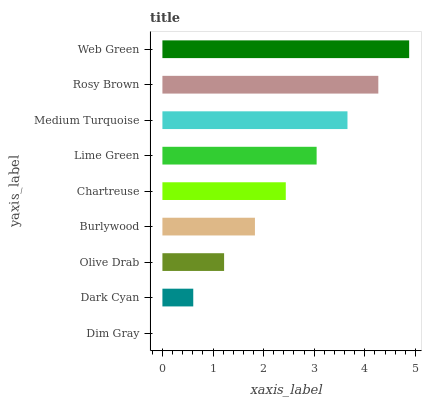Is Dim Gray the minimum?
Answer yes or no. Yes. Is Web Green the maximum?
Answer yes or no. Yes. Is Dark Cyan the minimum?
Answer yes or no. No. Is Dark Cyan the maximum?
Answer yes or no. No. Is Dark Cyan greater than Dim Gray?
Answer yes or no. Yes. Is Dim Gray less than Dark Cyan?
Answer yes or no. Yes. Is Dim Gray greater than Dark Cyan?
Answer yes or no. No. Is Dark Cyan less than Dim Gray?
Answer yes or no. No. Is Chartreuse the high median?
Answer yes or no. Yes. Is Chartreuse the low median?
Answer yes or no. Yes. Is Rosy Brown the high median?
Answer yes or no. No. Is Web Green the low median?
Answer yes or no. No. 